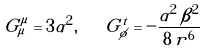<formula> <loc_0><loc_0><loc_500><loc_500>G _ { \mu } ^ { \mu } = 3 \alpha ^ { 2 } , \quad G _ { \phi } ^ { t } = - \frac { \alpha ^ { 2 } \, \beta ^ { 2 } } { 8 \, r ^ { 6 } }</formula> 